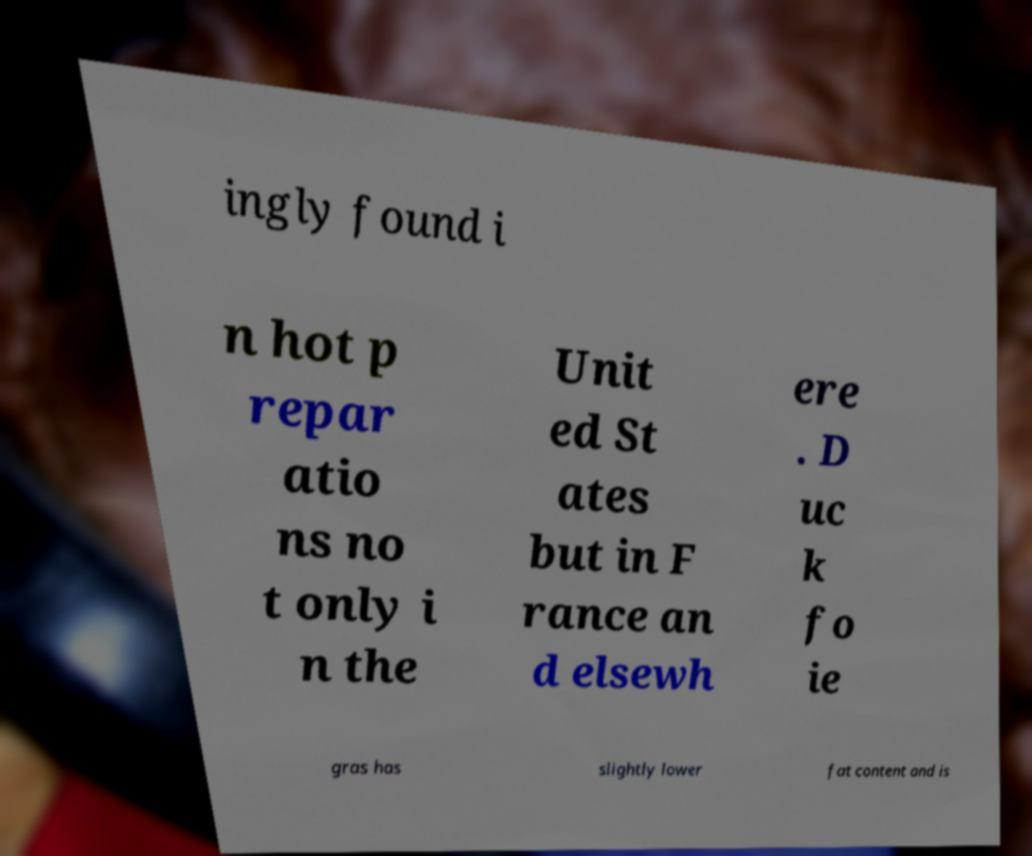Please read and relay the text visible in this image. What does it say? ingly found i n hot p repar atio ns no t only i n the Unit ed St ates but in F rance an d elsewh ere . D uc k fo ie gras has slightly lower fat content and is 